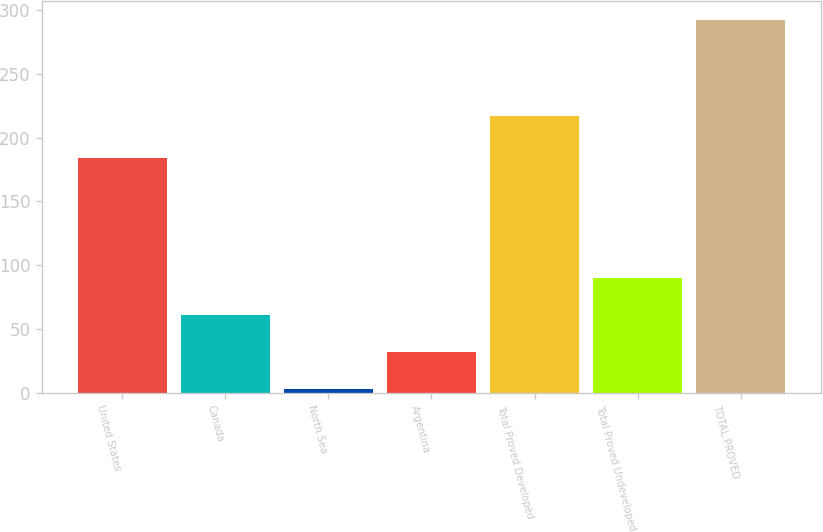Convert chart. <chart><loc_0><loc_0><loc_500><loc_500><bar_chart><fcel>United States<fcel>Canada<fcel>North Sea<fcel>Argentina<fcel>Total Proved Developed<fcel>Total Proved Undeveloped<fcel>TOTAL PROVED<nl><fcel>184<fcel>60.8<fcel>3<fcel>31.9<fcel>217<fcel>89.7<fcel>292<nl></chart> 